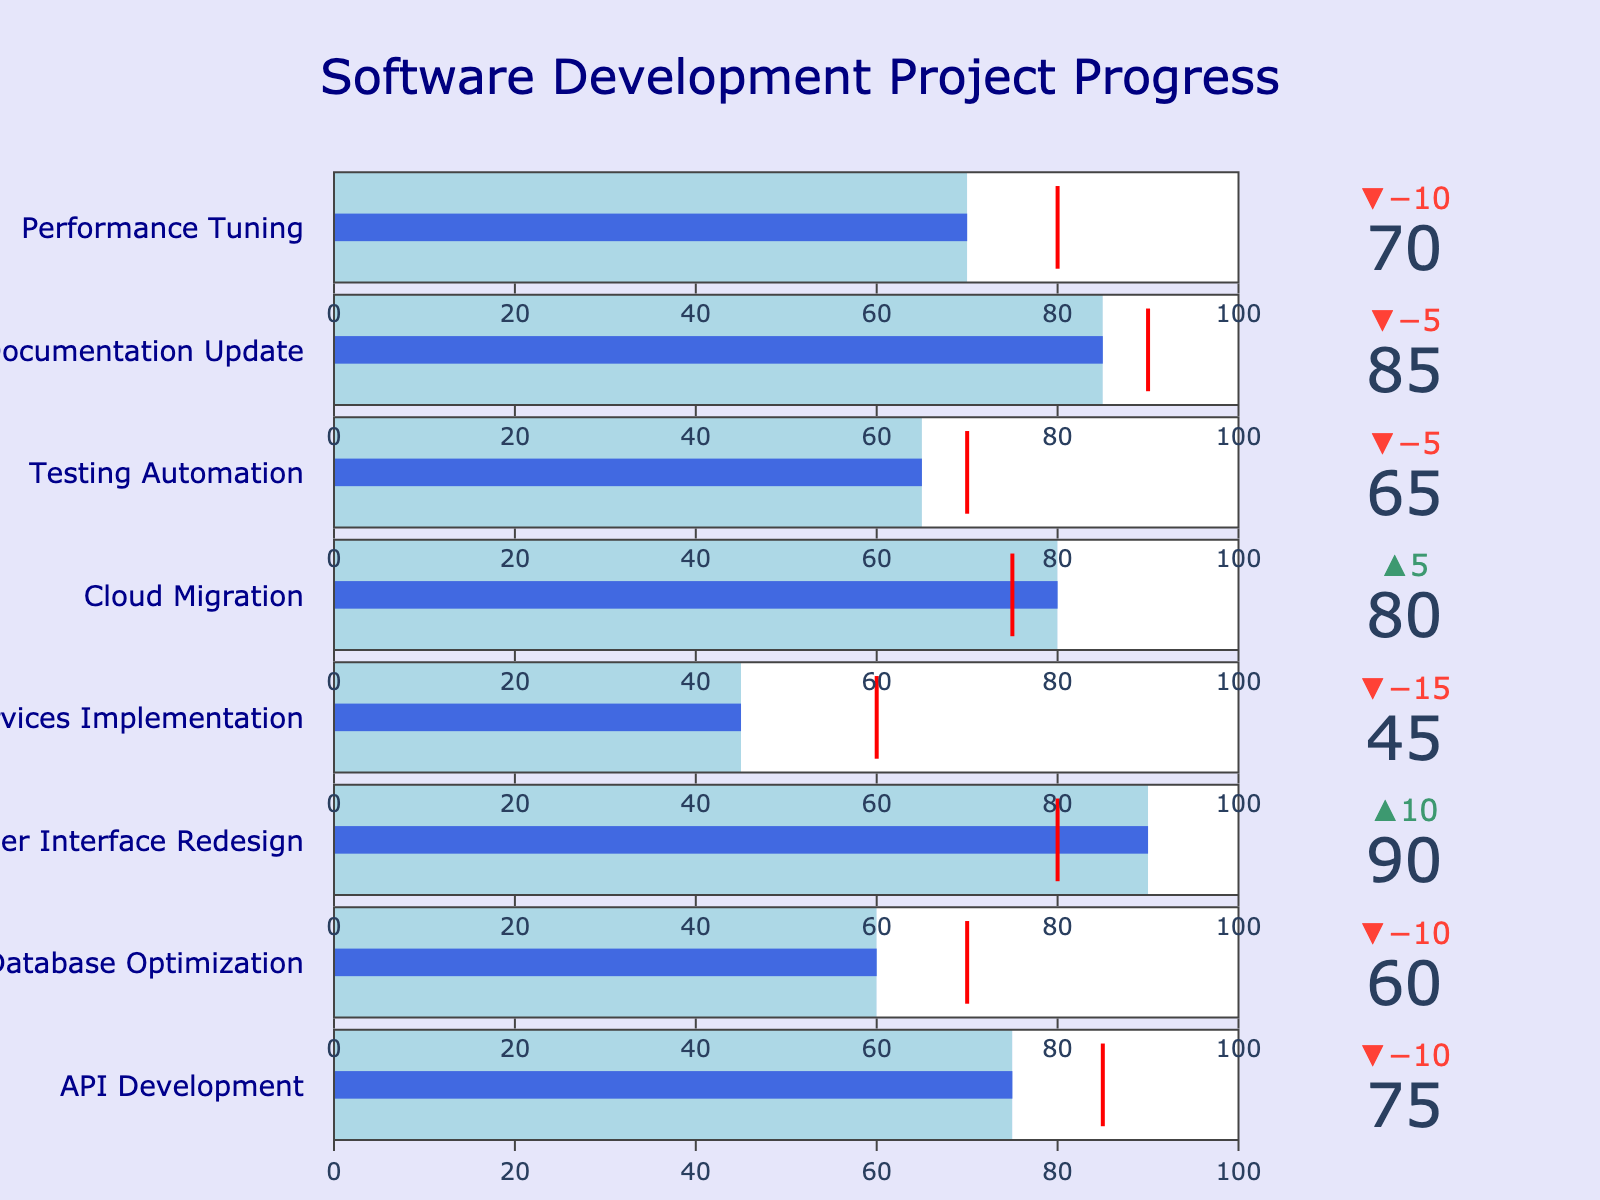What is the maximum value for the "Cloud Migration" project? The maximum value can be found directly from the "Maximum" column in the dataset. For "Cloud Migration," it is 100.
Answer: 100 Which project has the highest actual value? By comparing the "Actual" values across all projects, "User Interface Redesign" has the highest actual value of 90.
Answer: User Interface Redesign How many projects have an actual value greater than their target value? Compare the "Actual" values with the "Target" values for each project. Projects "User Interface Redesign" (90 > 80) and "Cloud Migration" (80 > 75) have actual values greater than their targets.
Answer: 2 What is the difference between the actual and target values for "Microservices Implementation"? The actual value for "Microservices Implementation" is 45, and the target value is 60. The difference is 60 - 45 = 15.
Answer: 15 Which project is the furthest behind its target in terms of actual vs. target value? Calculate the difference between the target and actual values for each project. The greatest difference is for "Microservices Implementation" (60 - 45 = 15).
Answer: Microservices Implementation What is the average actual value across all projects? Sum all the actual values and divide by the number of projects. (75 + 60 + 90 + 45 + 80 + 65 + 85 + 70) / 8 = 70.
Answer: 70 Which project has the closest actual value to its target value? Calculate the absolute difference between actual and target values for each project. The project "API Development" has the smallest difference (85 - 75 = 10).
Answer: API Development How does the performance of "Documentation Update" compare to "Database Optimization"? "Documentation Update" has an actual value of 85, and "Database Optimization" has an actual value of 60. Documentation Update is performing better than Database Optimization.
Answer: Documentation Update What is the sum of target values for all projects? Sum the target values from the dataset. 85 + 70 + 80 + 60 + 75 + 70 + 90 + 80 = 610.
Answer: 610 In which projects did the actual values exceed 70? The projects with actual values greater than 70 are "API Development" (75), "User Interface Redesign" (90), "Cloud Migration" (80), "Documentation Update" (85), and "Performance Tuning" (70, equal to but not exceeding 70).
Answer: 4 